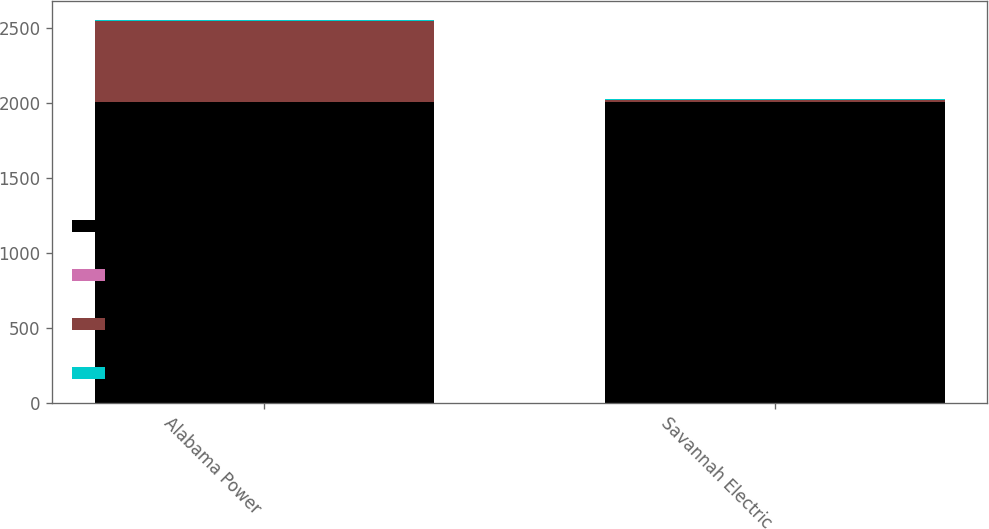Convert chart. <chart><loc_0><loc_0><loc_500><loc_500><stacked_bar_chart><ecel><fcel>Alabama Power<fcel>Savannah Electric<nl><fcel>MATURITY<fcel>2007<fcel>2007<nl><fcel>WEIGHTED AVERAGE  FIXED RATE PAID<fcel>2.01<fcel>2.5<nl><fcel>NOTIONAL  AMOUNT<fcel>536<fcel>14<nl><fcel>FAIR VALUE GAIN/LOSS<fcel>7.3<fcel>0.3<nl></chart> 